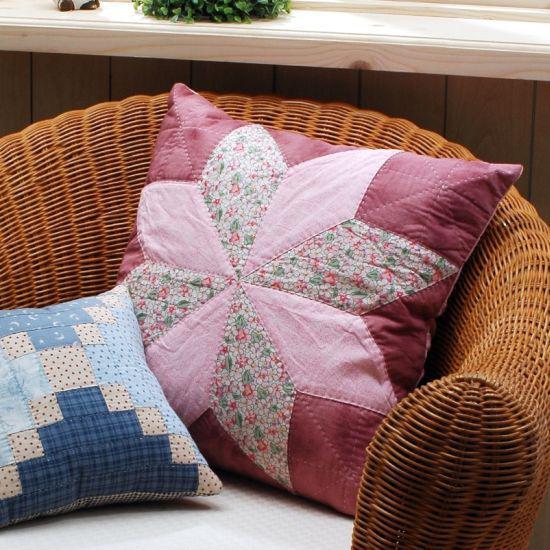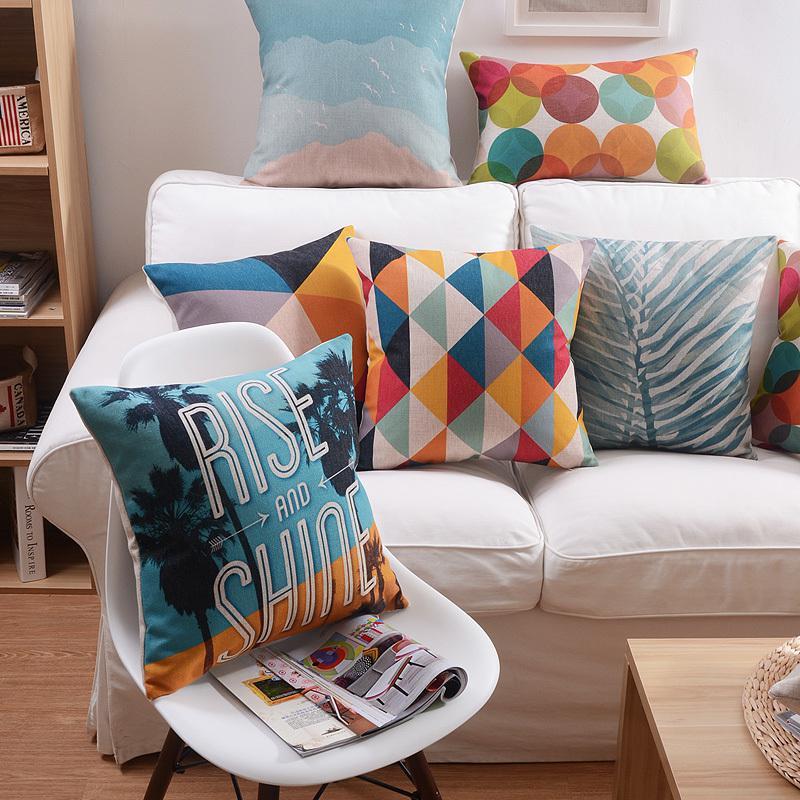The first image is the image on the left, the second image is the image on the right. Analyze the images presented: Is the assertion "There are stuffed animals on a bed." valid? Answer yes or no. No. 